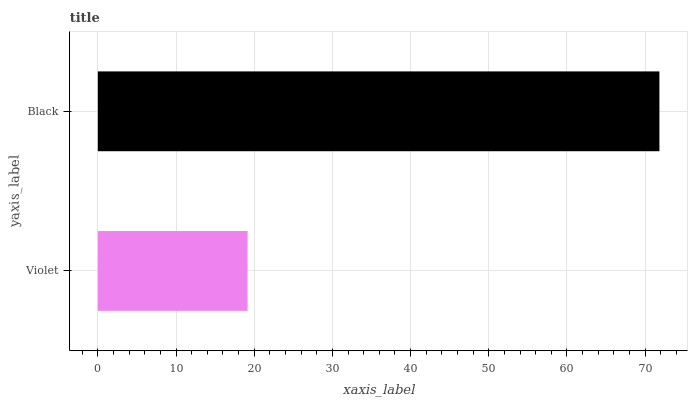Is Violet the minimum?
Answer yes or no. Yes. Is Black the maximum?
Answer yes or no. Yes. Is Black the minimum?
Answer yes or no. No. Is Black greater than Violet?
Answer yes or no. Yes. Is Violet less than Black?
Answer yes or no. Yes. Is Violet greater than Black?
Answer yes or no. No. Is Black less than Violet?
Answer yes or no. No. Is Black the high median?
Answer yes or no. Yes. Is Violet the low median?
Answer yes or no. Yes. Is Violet the high median?
Answer yes or no. No. Is Black the low median?
Answer yes or no. No. 